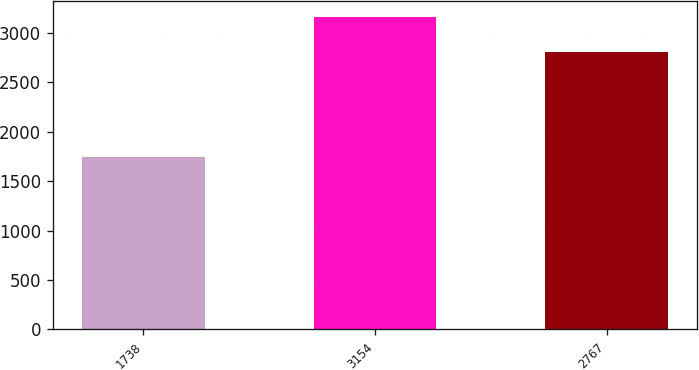Convert chart. <chart><loc_0><loc_0><loc_500><loc_500><bar_chart><fcel>1738<fcel>3154<fcel>2767<nl><fcel>1749<fcel>3166<fcel>2813<nl></chart> 